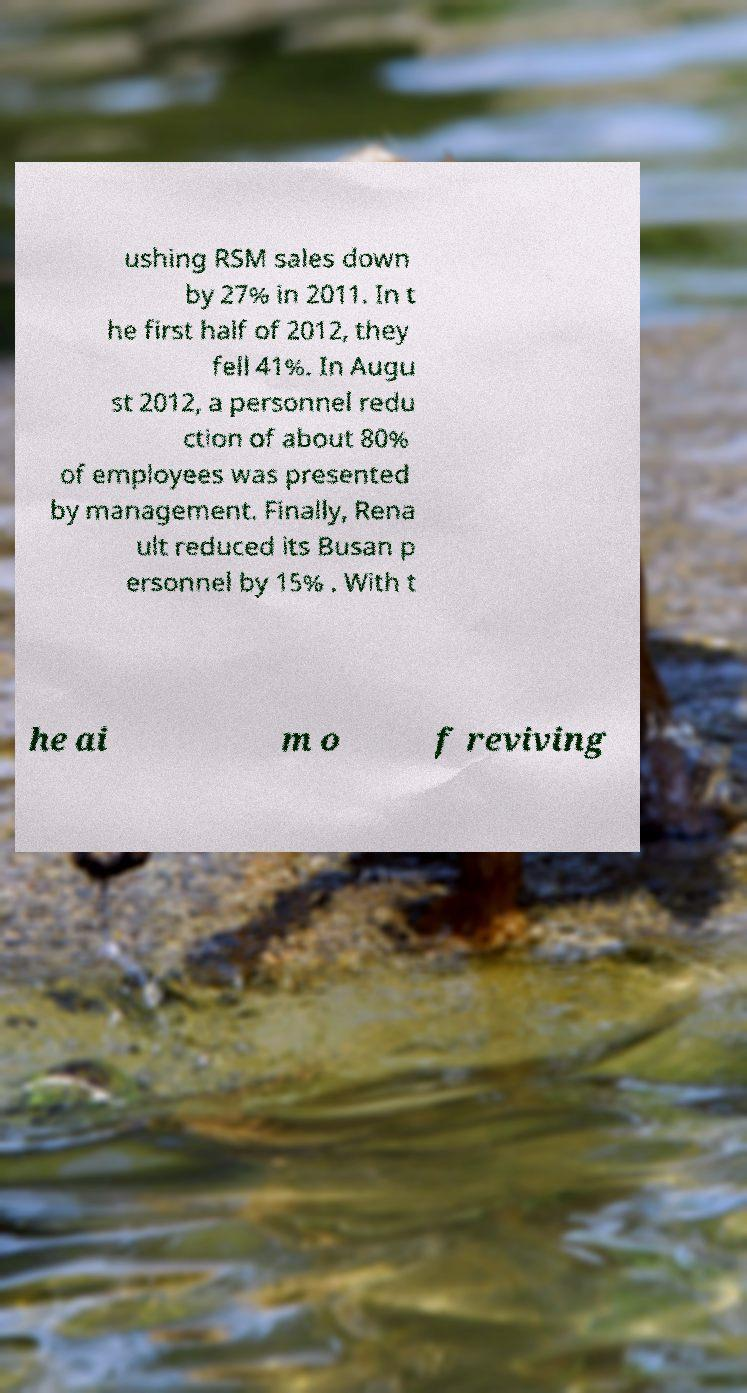Please read and relay the text visible in this image. What does it say? ushing RSM sales down by 27% in 2011. In t he first half of 2012, they fell 41%. In Augu st 2012, a personnel redu ction of about 80% of employees was presented by management. Finally, Rena ult reduced its Busan p ersonnel by 15% . With t he ai m o f reviving 